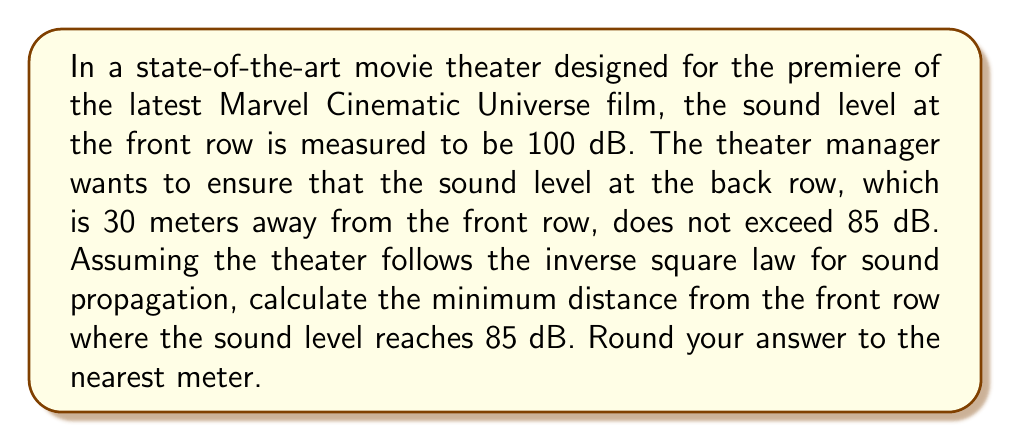Could you help me with this problem? Let's approach this step-by-step:

1) The inverse square law for sound intensity states that the intensity is inversely proportional to the square of the distance from the source. We can express this using the following formula:

   $$I_2 = I_1 \cdot \left(\frac{r_1}{r_2}\right)^2$$

   where $I_1$ and $I_2$ are the intensities at distances $r_1$ and $r_2$ respectively.

2) However, we're dealing with decibel levels, not intensities directly. The relationship between intensity and decibel level is logarithmic:

   $$L = 10 \log_{10}\left(\frac{I}{I_0}\right)$$

   where $L$ is the sound level in dB, $I$ is the intensity, and $I_0$ is a reference intensity.

3) We can combine these concepts to relate the decibel levels at two different distances:

   $$L_2 = L_1 - 20 \log_{10}\left(\frac{r_2}{r_1}\right)$$

4) In our problem:
   $L_1 = 100$ dB (front row)
   $L_2 = 85$ dB (target level)
   $r_1 = 1$ m (assuming front row is 1 meter from the source)
   $r_2 = $ unknown (what we're solving for)

5) Plugging these into our equation:

   $$85 = 100 - 20 \log_{10}\left(\frac{r_2}{1}\right)$$

6) Solving for $r_2$:

   $$-15 = -20 \log_{10}(r_2)$$
   $$0.75 = \log_{10}(r_2)$$
   $$10^{0.75} = r_2$$
   $$r_2 \approx 5.62$$

7) Rounding to the nearest meter:

   $r_2 = 6$ meters

Therefore, the sound level reaches 85 dB at approximately 6 meters from the front row.
Answer: 6 meters 